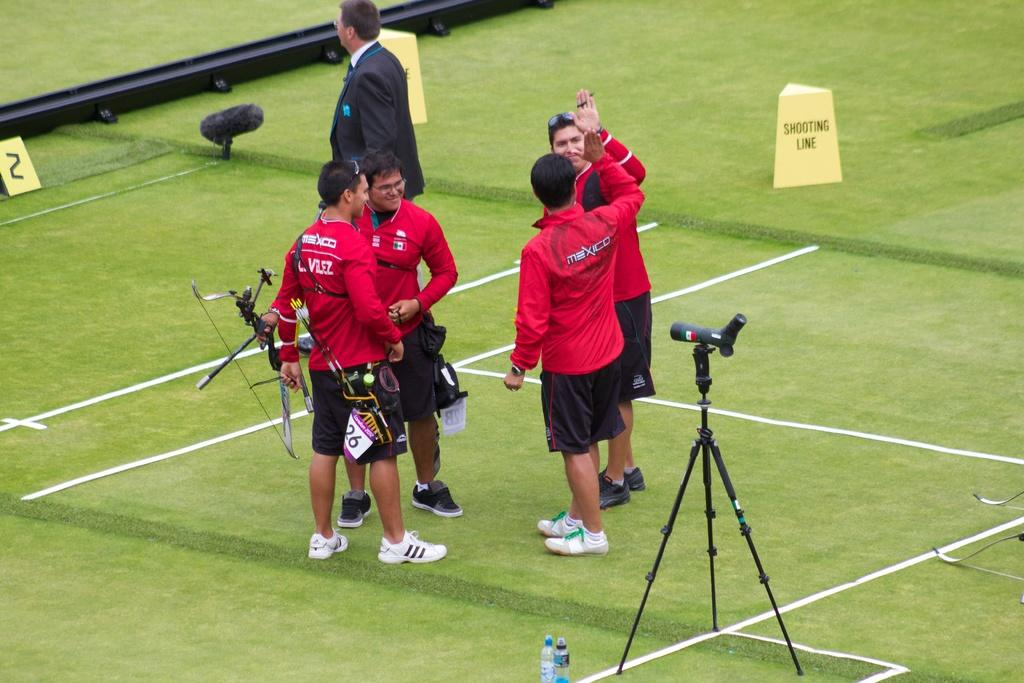What can be seen in the top corners of the image? There are objects with text in the top left and right corners of the image. How many people are in the foreground of the image? There are five people in the foreground of the image. What are two of the people doing in the image? Two of the people are holding objects. What is located at the bottom of the image? There is a grass mat at the bottom of the image. What type of heart-shaped parcel is being ordered by one of the people in the image? There is no heart-shaped parcel or order present in the image. 